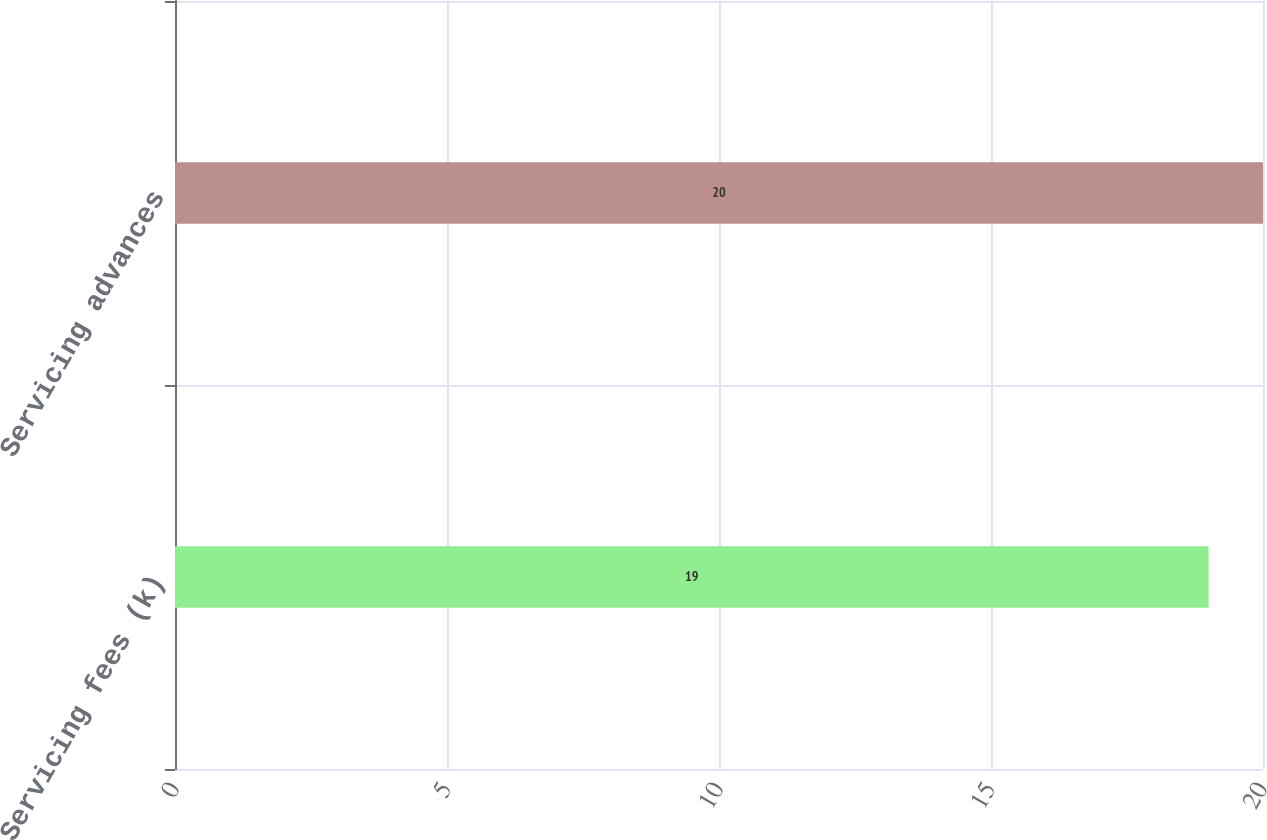Convert chart to OTSL. <chart><loc_0><loc_0><loc_500><loc_500><bar_chart><fcel>Servicing fees (k)<fcel>Servicing advances<nl><fcel>19<fcel>20<nl></chart> 